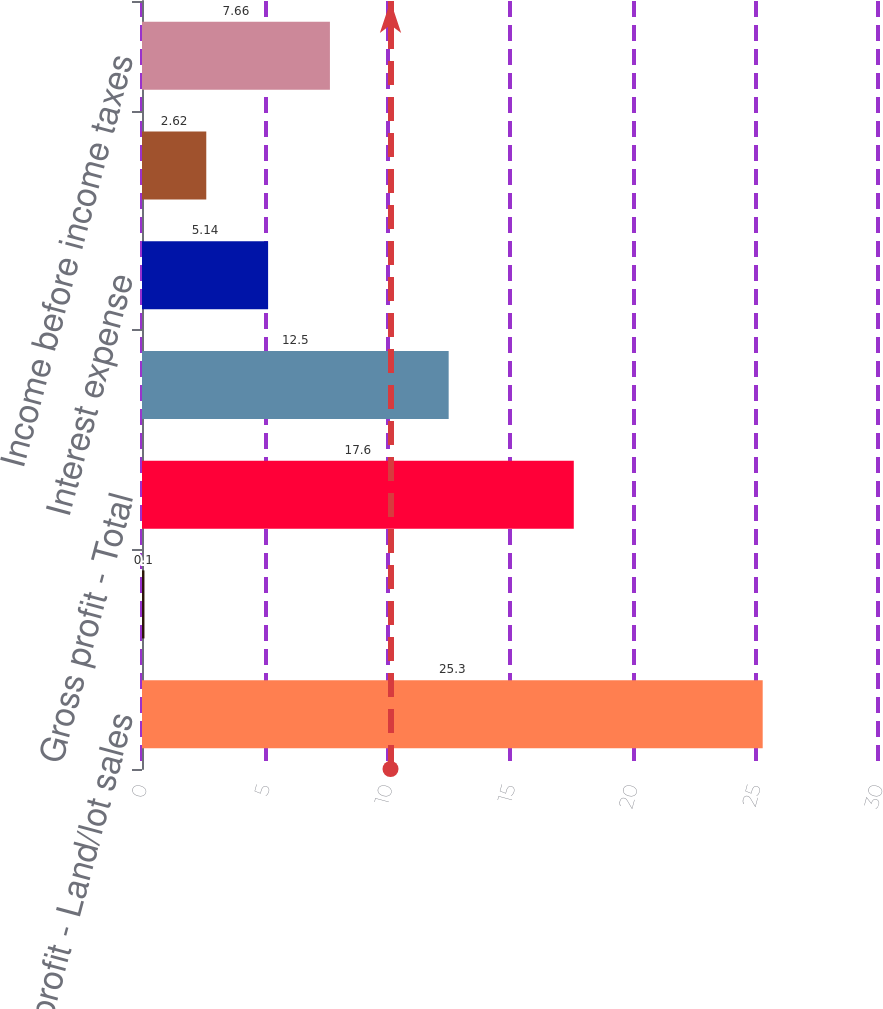<chart> <loc_0><loc_0><loc_500><loc_500><bar_chart><fcel>Gross profit - Land/lot sales<fcel>Effect of inventory and land<fcel>Gross profit - Total<fcel>Selling general and<fcel>Interest expense<fcel>Other (income)<fcel>Income before income taxes<nl><fcel>25.3<fcel>0.1<fcel>17.6<fcel>12.5<fcel>5.14<fcel>2.62<fcel>7.66<nl></chart> 